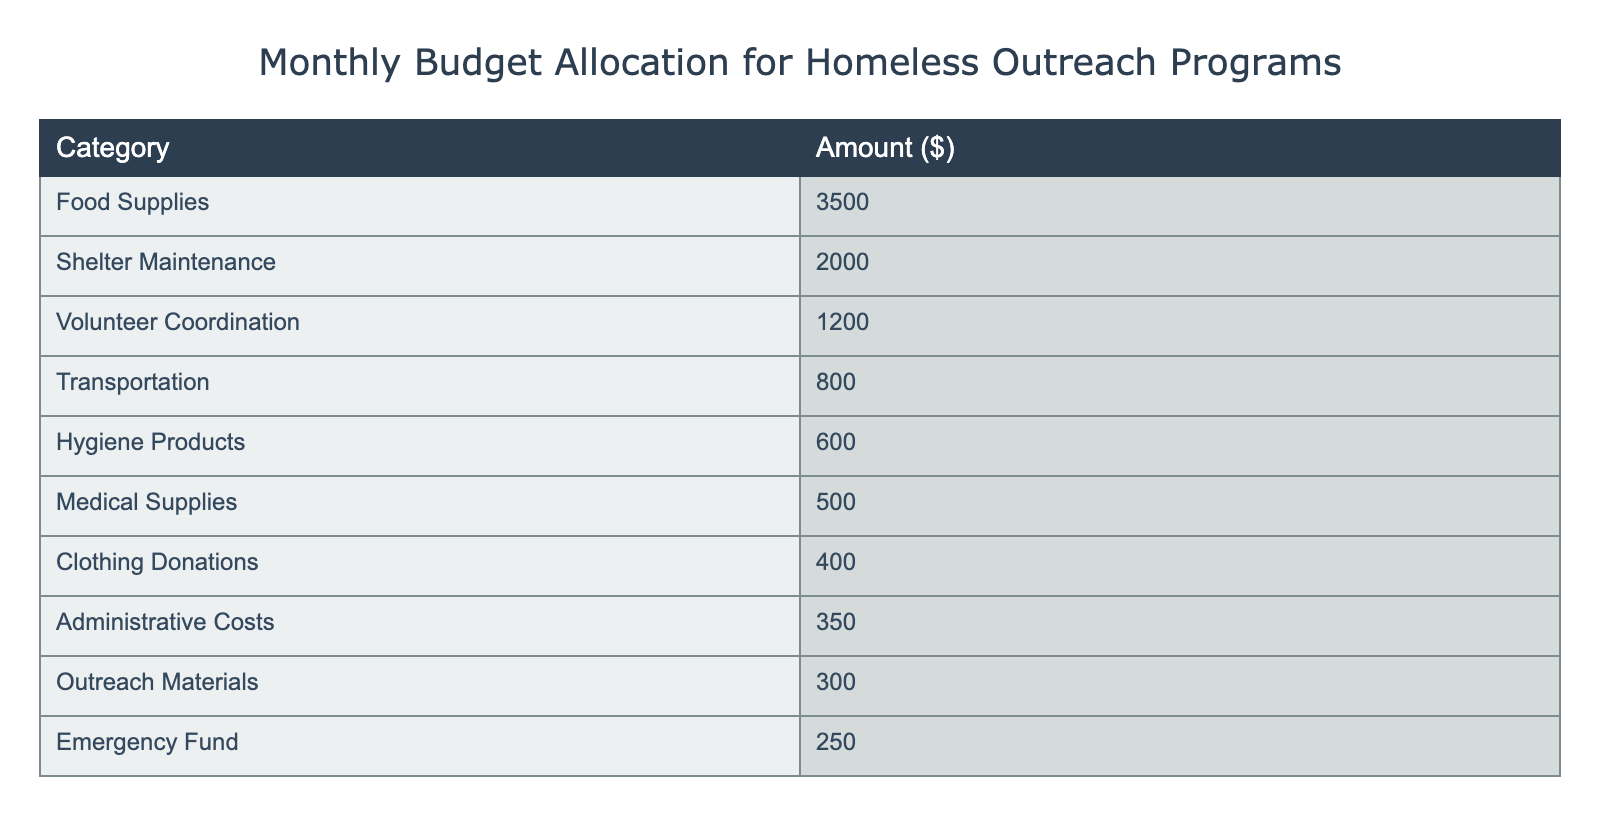What is the total amount allocated for food supplies? The table shows that the amount allocated for food supplies is 3500 dollars. Therefore, the answer is directly retrieved from the table without any calculations needed.
Answer: 3500 How much is allocated for volunteer coordination compared to hygiene products? The amount for volunteer coordination is 1200 dollars, while hygiene products receive 600 dollars. To compare, we see that volunteer coordination has 600 dollars more than hygiene products (1200 - 600 = 600).
Answer: 600 more Is the allocation for medical supplies more than the allocation for clothing donations? The table indicates that medical supplies are allocated 500 dollars, while clothing donations receive 400 dollars. Since 500 is greater than 400, the statement is true.
Answer: Yes What is the combined total for transportation and administrative costs? The table shows transportation costs at 800 dollars and administrative costs at 350 dollars. To find the combined total, we add these two amounts together: 800 + 350 = 1150 dollars.
Answer: 1150 If we sum all allocations for food supplies, shelter maintenance, and volunteer coordination, what is the total? According to the table, food supplies amount to 3500 dollars, shelter maintenance is 2000 dollars, and volunteer coordination is 1200 dollars. Summing these three amounts: 3500 + 2000 + 1200 = 6700 dollars gives the total allocation for these categories.
Answer: 6700 What percentage of the total budget is allocated to hygiene products? The total budget is calculated by adding up all the individual allocations: 3500 + 2000 + 1200 + 800 + 600 + 500 + 400 + 350 + 300 + 250 =  8550 dollars. The allocation for hygiene products is 600 dollars. To find the percentage: (600 / 8550) * 100 = 7.0 percent.
Answer: 7.0 percent Is the total of emergency fund and outreach materials greater than the amount for clothing donations? The emergency fund is 250 dollars and outreach materials are 300 dollars. The sum is 250 + 300 = 550 dollars. The allocation for clothing donations is 400 dollars. Since 550 is greater than 400, the statement is true.
Answer: Yes What is the average budget allocation for all categories? The total allocation is 8550 dollars and there are 10 categories. To find the average, we divide the total by the number of categories: 8550 / 10 = 855 dollars.
Answer: 855 